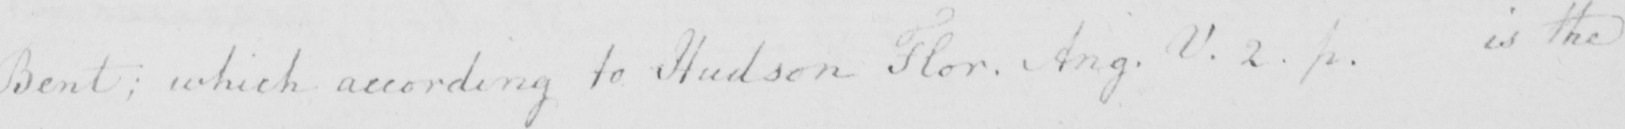Please transcribe the handwritten text in this image. Bent :  which according to Hudson Flor . Ang . V . 2 . p . is the 